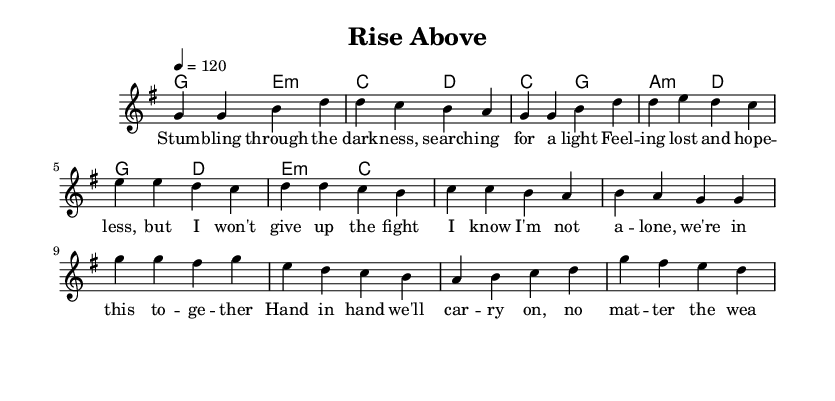What is the key signature of this music? The key signature is G major, which has one sharp (F#). This can be identified by looking at the key signature notation at the beginning of the piece.
Answer: G major What is the time signature of this piece? The time signature is 4/4, as indicated at the beginning of the score. This means there are four beats per measure with a quarter note receiving one beat.
Answer: 4/4 What tempo marking is indicated in the score? The tempo marking is 4 = 120, which means the quarter note should be played at a speed of 120 beats per minute. This can be found in the tempo indication at the beginning of the piece.
Answer: 120 How many lines of lyrics are provided in the verse? There are two lines of lyrics in the verse section as shown directly below the melody notes for the verse. This can be confirmed by counting the distinct lines of text provided.
Answer: 2 What chord is played during the chorus? The chorus features the chords G and D. These can be found in the chord section next to the melody for the chorus part.
Answer: G and D What is the primary theme of the lyrics in this piece? The primary theme of the lyrics is overcoming challenges and personal growth, indicated by phrases expressing resilience and support evident in the lyrics. This is a central element in both the verse and chorus.
Answer: Overcoming challenges In which musical section do we find the lines about "Hand in hand we'll carry on"? These lines appear in the pre-chorus, as the lyrics are labeled accordingly and placed in that section of the sheet music. This can be confirmed by checking the structure label above the lyrics.
Answer: Pre-Chorus 